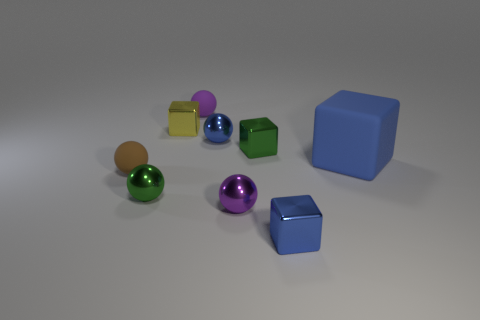Subtract all blue blocks. How many blocks are left? 2 Subtract all tiny green shiny cubes. How many cubes are left? 3 Subtract all balls. How many objects are left? 4 Subtract 3 balls. How many balls are left? 2 Subtract all brown cylinders. How many brown spheres are left? 1 Subtract all small blue objects. Subtract all small purple spheres. How many objects are left? 5 Add 9 brown objects. How many brown objects are left? 10 Add 9 small yellow metal cubes. How many small yellow metal cubes exist? 10 Subtract 1 purple balls. How many objects are left? 8 Subtract all green balls. Subtract all red cylinders. How many balls are left? 4 